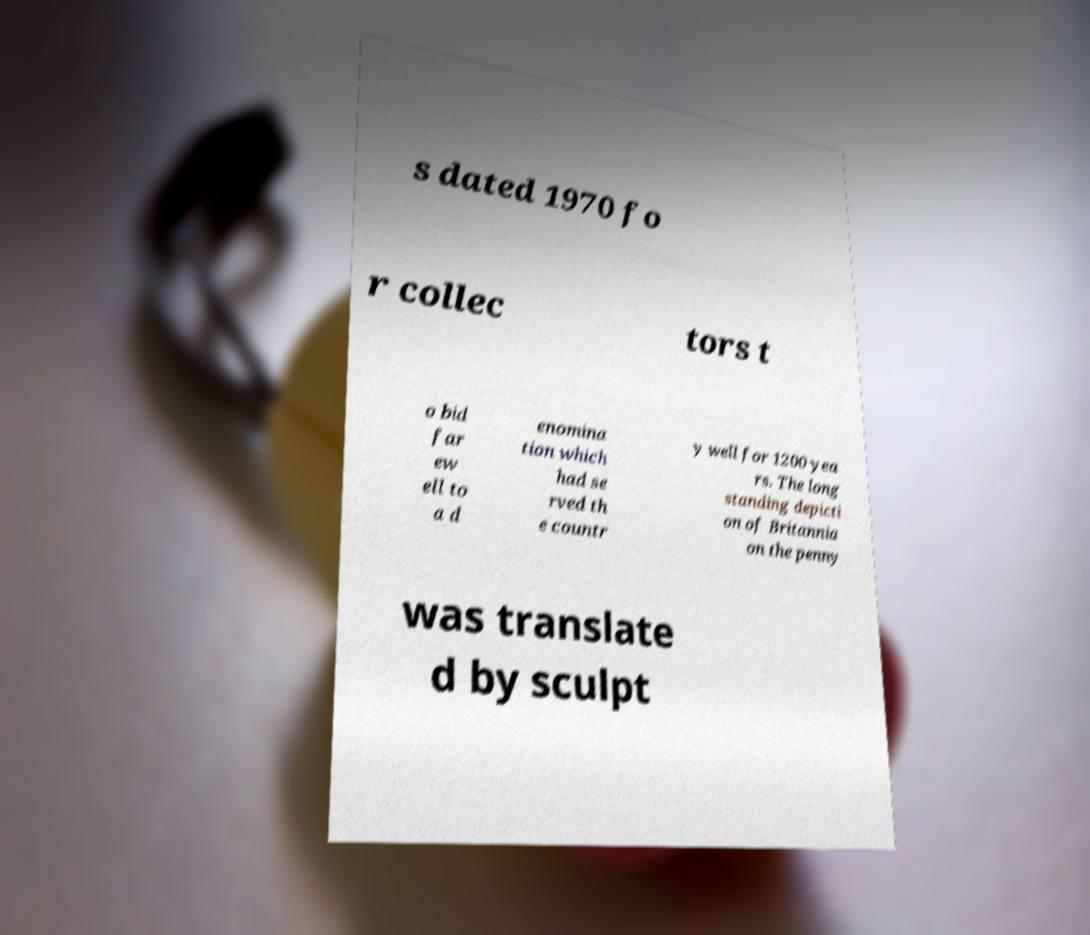Please read and relay the text visible in this image. What does it say? s dated 1970 fo r collec tors t o bid far ew ell to a d enomina tion which had se rved th e countr y well for 1200 yea rs. The long standing depicti on of Britannia on the penny was translate d by sculpt 